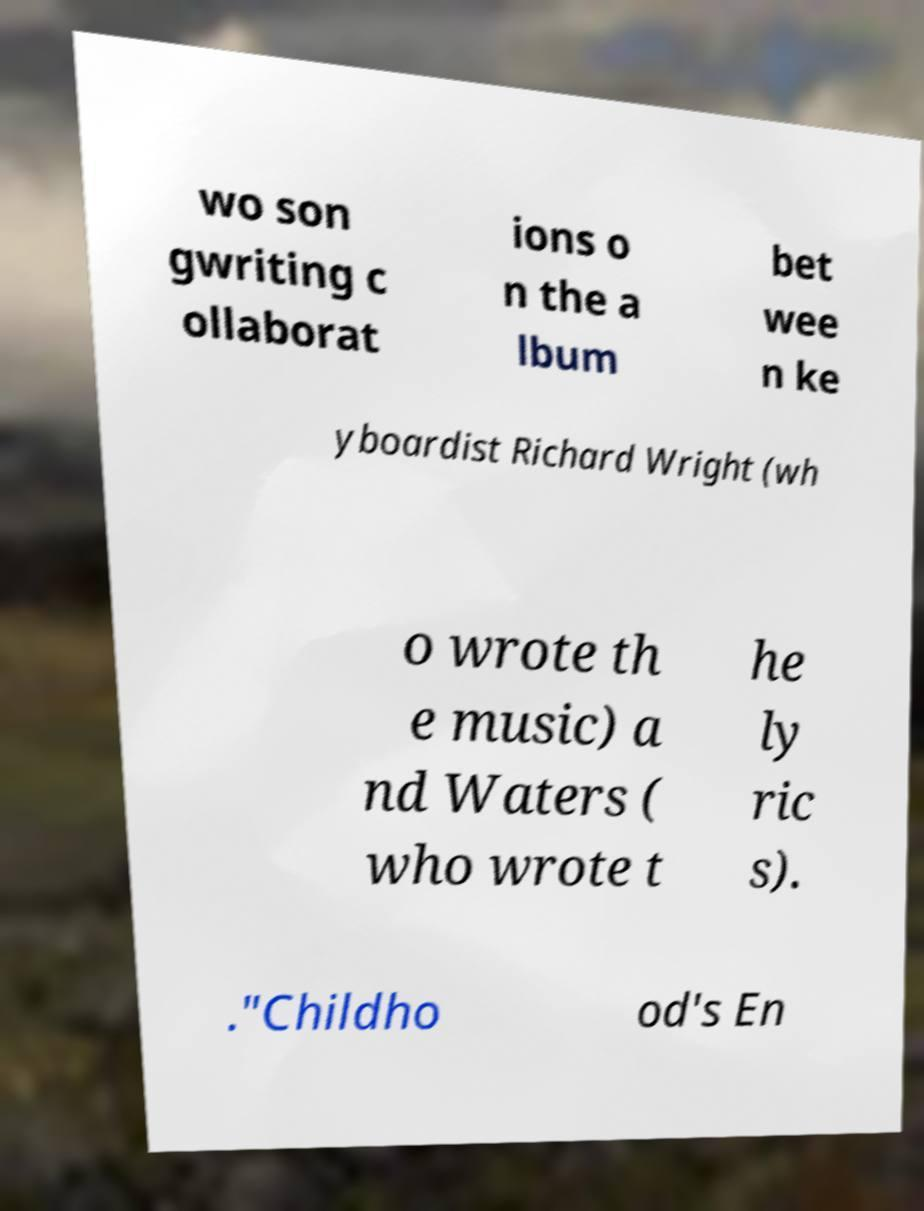I need the written content from this picture converted into text. Can you do that? wo son gwriting c ollaborat ions o n the a lbum bet wee n ke yboardist Richard Wright (wh o wrote th e music) a nd Waters ( who wrote t he ly ric s). ."Childho od's En 